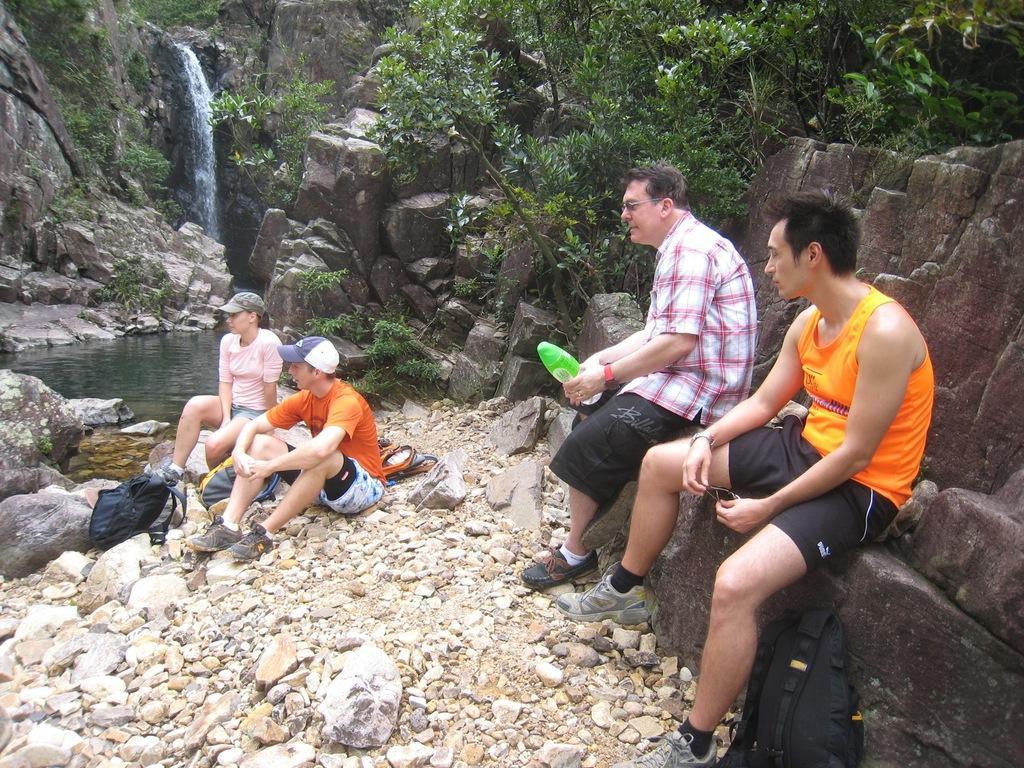Can you describe this image briefly? In this image there are group of persons sitting. The man in the center is sitting on a rock and holding a green colour bottle in his hand. In the front there is a bag which is black in colour. On the ground there are stones in the background there are mountains, trees, and there is a waterfall which is visible. 